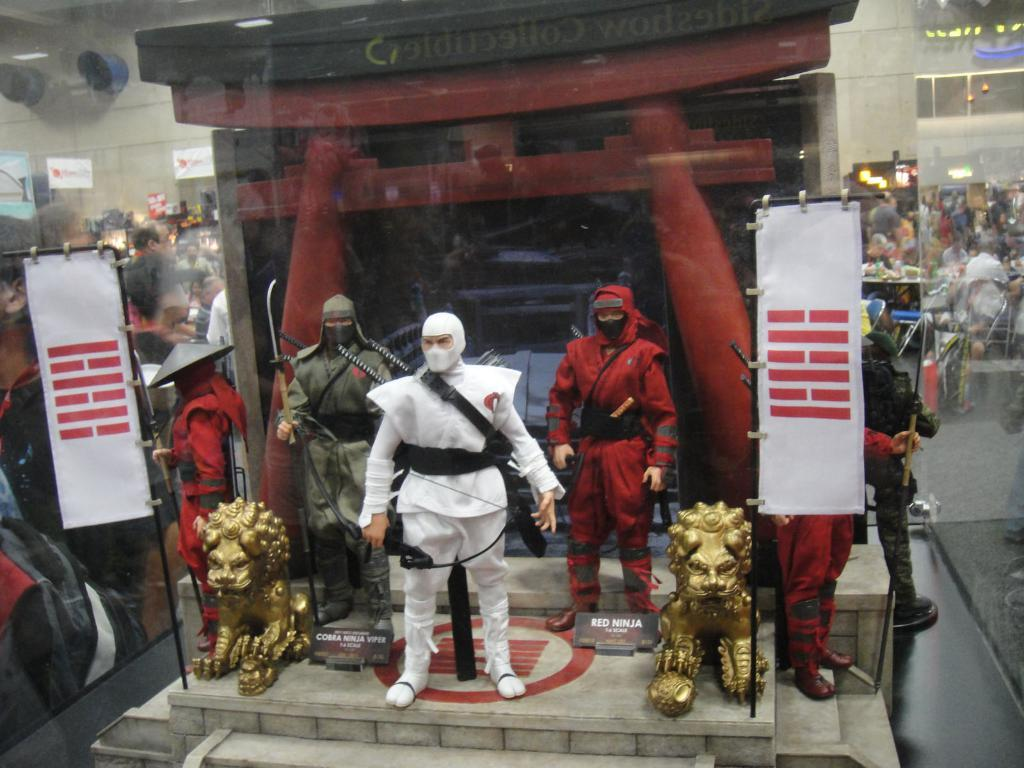What object is present in the image that can hold a liquid? There is a glass in the image. What can be seen in the foreground of the image? There are statues in the foreground of the image. What is inside the glass in the image? The glass contains people and other objects on the left and right corners. How does the pollution affect the jellyfish in the image? There is no pollution or jellyfish present in the image. 